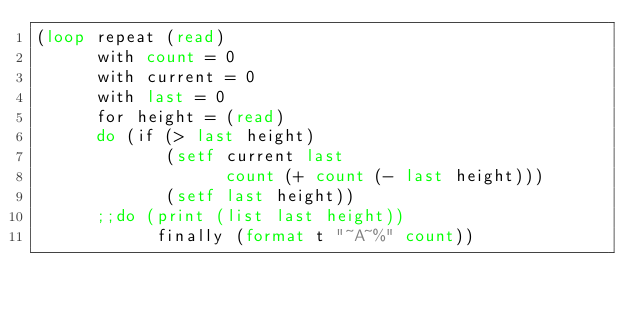<code> <loc_0><loc_0><loc_500><loc_500><_Lisp_>(loop repeat (read)
      with count = 0
      with current = 0
      with last = 0
      for height = (read)
      do (if (> last height)
             (setf current last
                   count (+ count (- last height)))
             (setf last height))
      ;;do (print (list last height))
            finally (format t "~A~%" count))</code> 